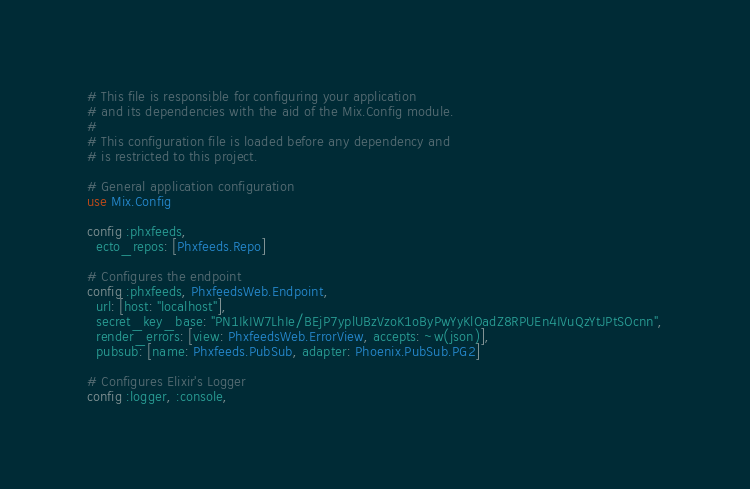<code> <loc_0><loc_0><loc_500><loc_500><_Elixir_># This file is responsible for configuring your application
# and its dependencies with the aid of the Mix.Config module.
#
# This configuration file is loaded before any dependency and
# is restricted to this project.

# General application configuration
use Mix.Config

config :phxfeeds,
  ecto_repos: [Phxfeeds.Repo]

# Configures the endpoint
config :phxfeeds, PhxfeedsWeb.Endpoint,
  url: [host: "localhost"],
  secret_key_base: "PN1IkIW7LhIe/BEjP7yplUBzVzoK1oByPwYyKlOadZ8RPUEn4IVuQzYtJPtSOcnn",
  render_errors: [view: PhxfeedsWeb.ErrorView, accepts: ~w(json)],
  pubsub: [name: Phxfeeds.PubSub, adapter: Phoenix.PubSub.PG2]

# Configures Elixir's Logger
config :logger, :console,</code> 